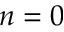<formula> <loc_0><loc_0><loc_500><loc_500>n = 0</formula> 